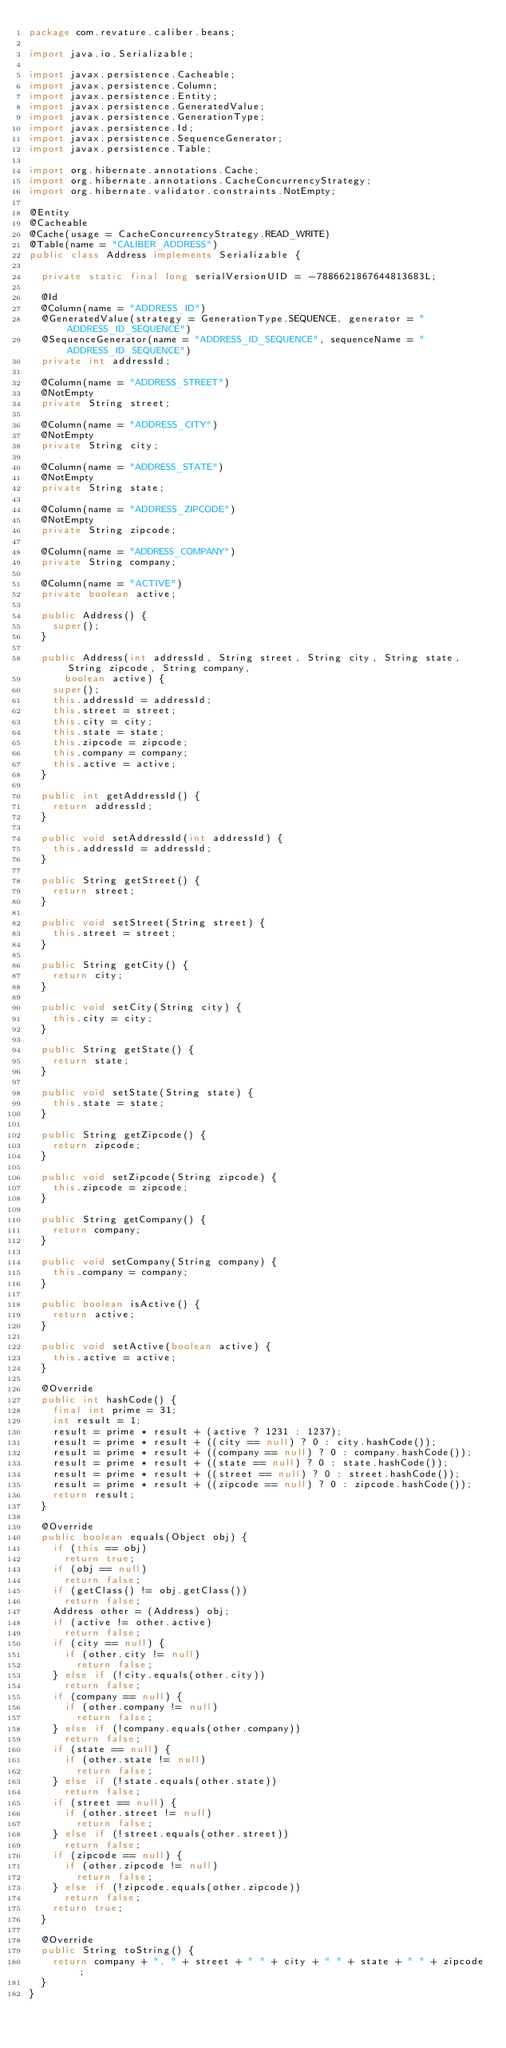Convert code to text. <code><loc_0><loc_0><loc_500><loc_500><_Java_>package com.revature.caliber.beans;

import java.io.Serializable;

import javax.persistence.Cacheable;
import javax.persistence.Column;
import javax.persistence.Entity;
import javax.persistence.GeneratedValue;
import javax.persistence.GenerationType;
import javax.persistence.Id;
import javax.persistence.SequenceGenerator;
import javax.persistence.Table;

import org.hibernate.annotations.Cache;
import org.hibernate.annotations.CacheConcurrencyStrategy;
import org.hibernate.validator.constraints.NotEmpty;

@Entity
@Cacheable
@Cache(usage = CacheConcurrencyStrategy.READ_WRITE)
@Table(name = "CALIBER_ADDRESS")
public class Address implements Serializable {

	private static final long serialVersionUID = -7886621867644813683L;

	@Id
	@Column(name = "ADDRESS_ID")
	@GeneratedValue(strategy = GenerationType.SEQUENCE, generator = "ADDRESS_ID_SEQUENCE")
	@SequenceGenerator(name = "ADDRESS_ID_SEQUENCE", sequenceName = "ADDRESS_ID_SEQUENCE")
	private int addressId;

	@Column(name = "ADDRESS_STREET")
	@NotEmpty
	private String street;

	@Column(name = "ADDRESS_CITY")
	@NotEmpty
	private String city;

	@Column(name = "ADDRESS_STATE")
	@NotEmpty
	private String state;

	@Column(name = "ADDRESS_ZIPCODE")
	@NotEmpty
	private String zipcode;

	@Column(name = "ADDRESS_COMPANY")
	private String company;

	@Column(name = "ACTIVE")
	private boolean active;

	public Address() {
		super();
	}

	public Address(int addressId, String street, String city, String state, String zipcode, String company,
			boolean active) {
		super();
		this.addressId = addressId;
		this.street = street;
		this.city = city;
		this.state = state;
		this.zipcode = zipcode;
		this.company = company;
		this.active = active;
	}

	public int getAddressId() {
		return addressId;
	}

	public void setAddressId(int addressId) {
		this.addressId = addressId;
	}

	public String getStreet() {
		return street;
	}

	public void setStreet(String street) {
		this.street = street;
	}

	public String getCity() {
		return city;
	}

	public void setCity(String city) {
		this.city = city;
	}

	public String getState() {
		return state;
	}

	public void setState(String state) {
		this.state = state;
	}

	public String getZipcode() {
		return zipcode;
	}

	public void setZipcode(String zipcode) {
		this.zipcode = zipcode;
	}

	public String getCompany() {
		return company;
	}

	public void setCompany(String company) {
		this.company = company;
	}

	public boolean isActive() {
		return active;
	}

	public void setActive(boolean active) {
		this.active = active;
	}

	@Override
	public int hashCode() {
		final int prime = 31;
		int result = 1;
		result = prime * result + (active ? 1231 : 1237);
		result = prime * result + ((city == null) ? 0 : city.hashCode());
		result = prime * result + ((company == null) ? 0 : company.hashCode());
		result = prime * result + ((state == null) ? 0 : state.hashCode());
		result = prime * result + ((street == null) ? 0 : street.hashCode());
		result = prime * result + ((zipcode == null) ? 0 : zipcode.hashCode());
		return result;
	}

	@Override
	public boolean equals(Object obj) {
		if (this == obj)
			return true;
		if (obj == null)
			return false;
		if (getClass() != obj.getClass())
			return false;
		Address other = (Address) obj;
		if (active != other.active)
			return false;
		if (city == null) {
			if (other.city != null)
				return false;
		} else if (!city.equals(other.city))
			return false;
		if (company == null) {
			if (other.company != null)
				return false;
		} else if (!company.equals(other.company))
			return false;
		if (state == null) {
			if (other.state != null)
				return false;
		} else if (!state.equals(other.state))
			return false;
		if (street == null) {
			if (other.street != null)
				return false;
		} else if (!street.equals(other.street))
			return false;
		if (zipcode == null) {
			if (other.zipcode != null)
				return false;
		} else if (!zipcode.equals(other.zipcode))
			return false;
		return true;
	}

	@Override
	public String toString() {
		return company + ", " + street + " " + city + " " + state + " " + zipcode;
	}
}
</code> 